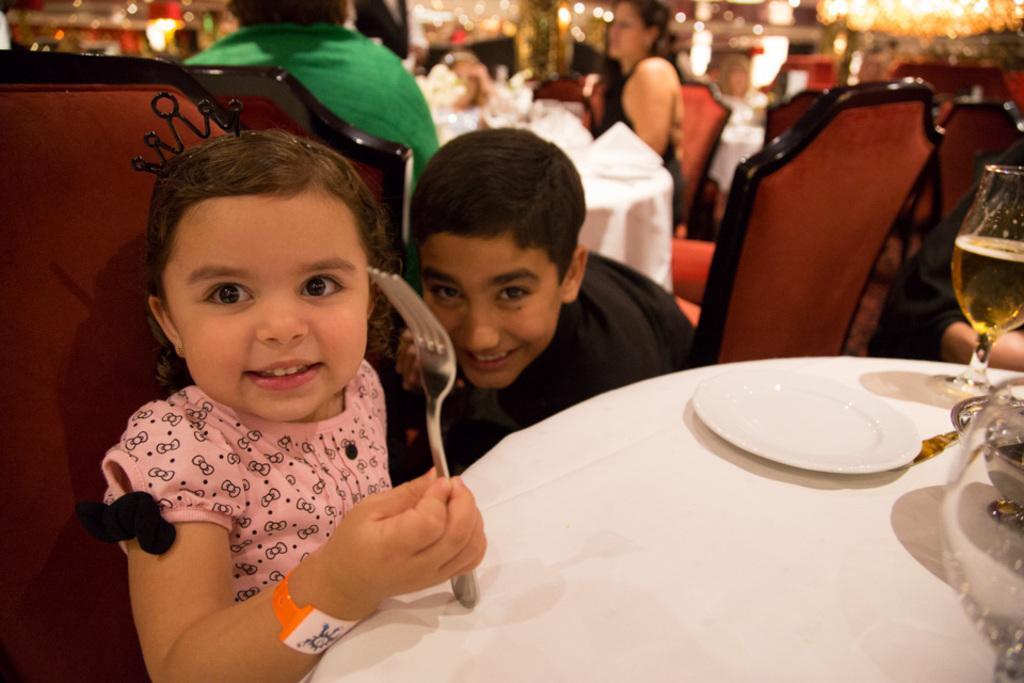How would you summarize this image in a sentence or two? She is a baby girl sitting on a chair. She is holding a spoon in her right hand and there is a pretty smile on her face. There is a boy who is sitting on a chair and he is on the center. In the background there is a woman sitting on a chair and she is on the right side. 